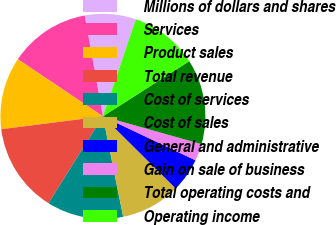<chart> <loc_0><loc_0><loc_500><loc_500><pie_chart><fcel>Millions of dollars and shares<fcel>Services<fcel>Product sales<fcel>Total revenue<fcel>Cost of services<fcel>Cost of sales<fcel>General and administrative<fcel>Gain on sale of business<fcel>Total operating costs and<fcel>Operating income<nl><fcel>8.05%<fcel>12.75%<fcel>11.41%<fcel>14.09%<fcel>12.08%<fcel>9.4%<fcel>5.37%<fcel>2.68%<fcel>13.42%<fcel>10.74%<nl></chart> 